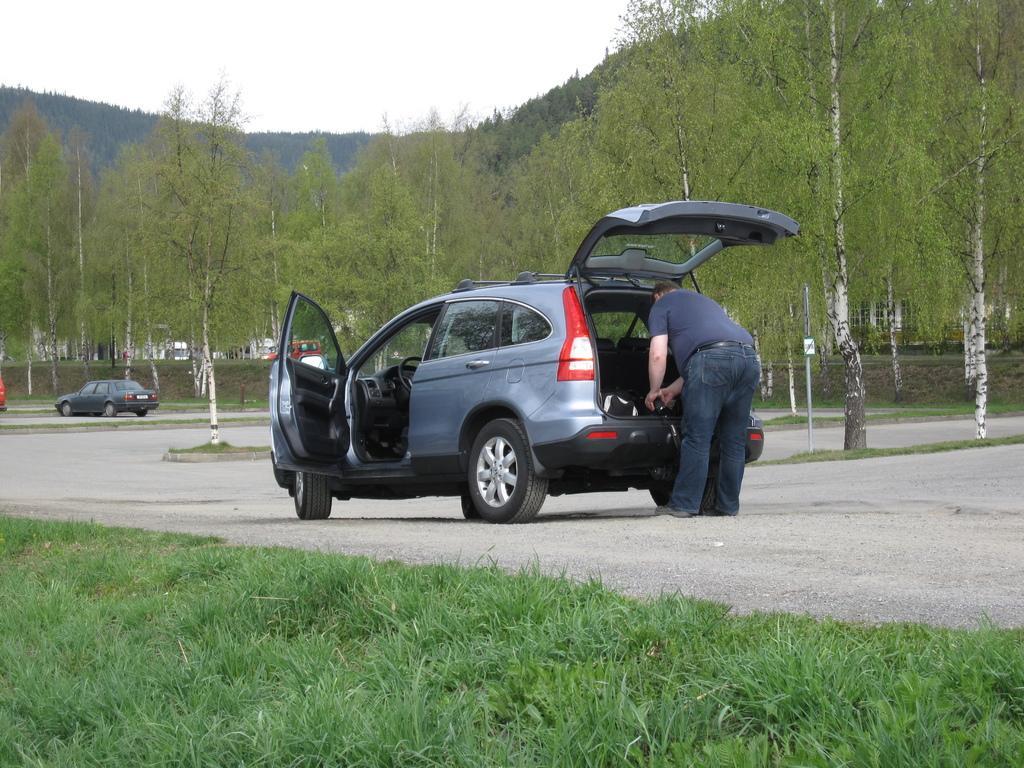Could you give a brief overview of what you see in this image? In this picture I can see the grass in front and on the road I see 2 cars and on the right side of this image I see a man near to the car and in the background I see the trees and the sky. 